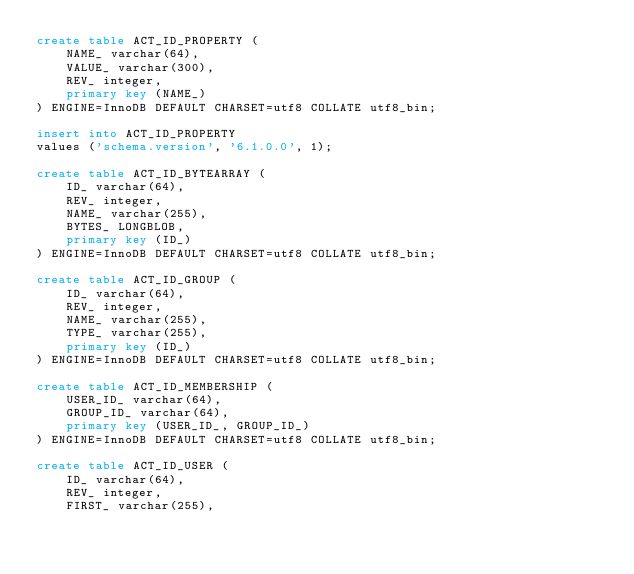<code> <loc_0><loc_0><loc_500><loc_500><_SQL_>create table ACT_ID_PROPERTY (
    NAME_ varchar(64),
    VALUE_ varchar(300),
    REV_ integer,
    primary key (NAME_)
) ENGINE=InnoDB DEFAULT CHARSET=utf8 COLLATE utf8_bin;

insert into ACT_ID_PROPERTY
values ('schema.version', '6.1.0.0', 1);

create table ACT_ID_BYTEARRAY (
    ID_ varchar(64),
    REV_ integer,
    NAME_ varchar(255),
    BYTES_ LONGBLOB,
    primary key (ID_)
) ENGINE=InnoDB DEFAULT CHARSET=utf8 COLLATE utf8_bin;

create table ACT_ID_GROUP (
    ID_ varchar(64),
    REV_ integer,
    NAME_ varchar(255),
    TYPE_ varchar(255),
    primary key (ID_)
) ENGINE=InnoDB DEFAULT CHARSET=utf8 COLLATE utf8_bin;

create table ACT_ID_MEMBERSHIP (
    USER_ID_ varchar(64),
    GROUP_ID_ varchar(64),
    primary key (USER_ID_, GROUP_ID_)
) ENGINE=InnoDB DEFAULT CHARSET=utf8 COLLATE utf8_bin;

create table ACT_ID_USER (
    ID_ varchar(64),
    REV_ integer,
    FIRST_ varchar(255),</code> 